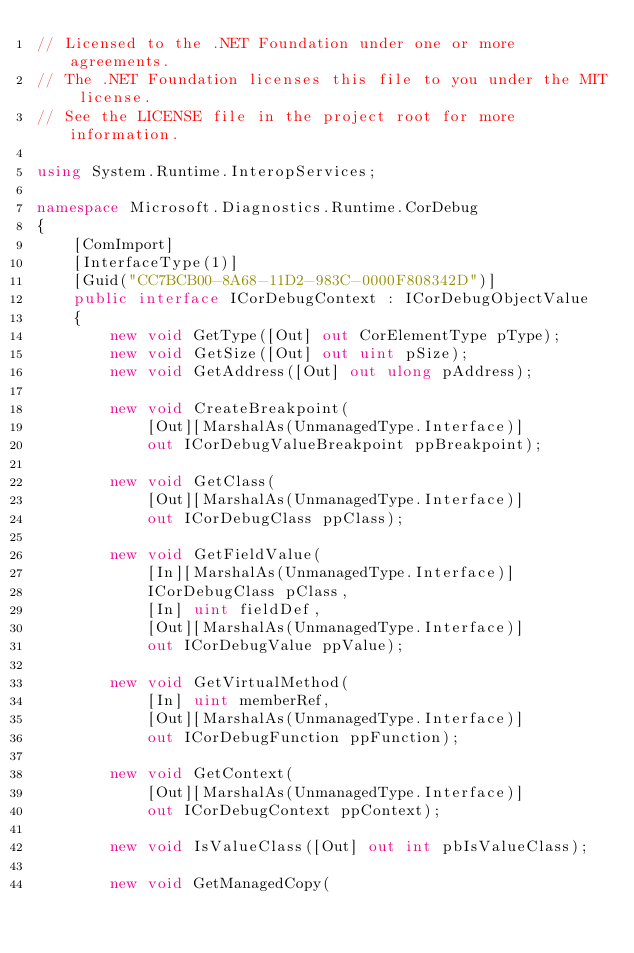Convert code to text. <code><loc_0><loc_0><loc_500><loc_500><_C#_>// Licensed to the .NET Foundation under one or more agreements.
// The .NET Foundation licenses this file to you under the MIT license.
// See the LICENSE file in the project root for more information.

using System.Runtime.InteropServices;

namespace Microsoft.Diagnostics.Runtime.CorDebug
{
    [ComImport]
    [InterfaceType(1)]
    [Guid("CC7BCB00-8A68-11D2-983C-0000F808342D")]
    public interface ICorDebugContext : ICorDebugObjectValue
    {
        new void GetType([Out] out CorElementType pType);
        new void GetSize([Out] out uint pSize);
        new void GetAddress([Out] out ulong pAddress);

        new void CreateBreakpoint(
            [Out][MarshalAs(UnmanagedType.Interface)]
            out ICorDebugValueBreakpoint ppBreakpoint);

        new void GetClass(
            [Out][MarshalAs(UnmanagedType.Interface)]
            out ICorDebugClass ppClass);

        new void GetFieldValue(
            [In][MarshalAs(UnmanagedType.Interface)]
            ICorDebugClass pClass,
            [In] uint fieldDef,
            [Out][MarshalAs(UnmanagedType.Interface)]
            out ICorDebugValue ppValue);

        new void GetVirtualMethod(
            [In] uint memberRef,
            [Out][MarshalAs(UnmanagedType.Interface)]
            out ICorDebugFunction ppFunction);

        new void GetContext(
            [Out][MarshalAs(UnmanagedType.Interface)]
            out ICorDebugContext ppContext);

        new void IsValueClass([Out] out int pbIsValueClass);

        new void GetManagedCopy(</code> 